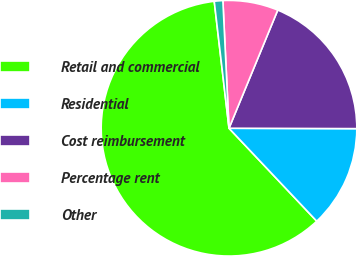<chart> <loc_0><loc_0><loc_500><loc_500><pie_chart><fcel>Retail and commercial<fcel>Residential<fcel>Cost reimbursement<fcel>Percentage rent<fcel>Other<nl><fcel>60.2%<fcel>12.91%<fcel>18.82%<fcel>6.99%<fcel>1.08%<nl></chart> 